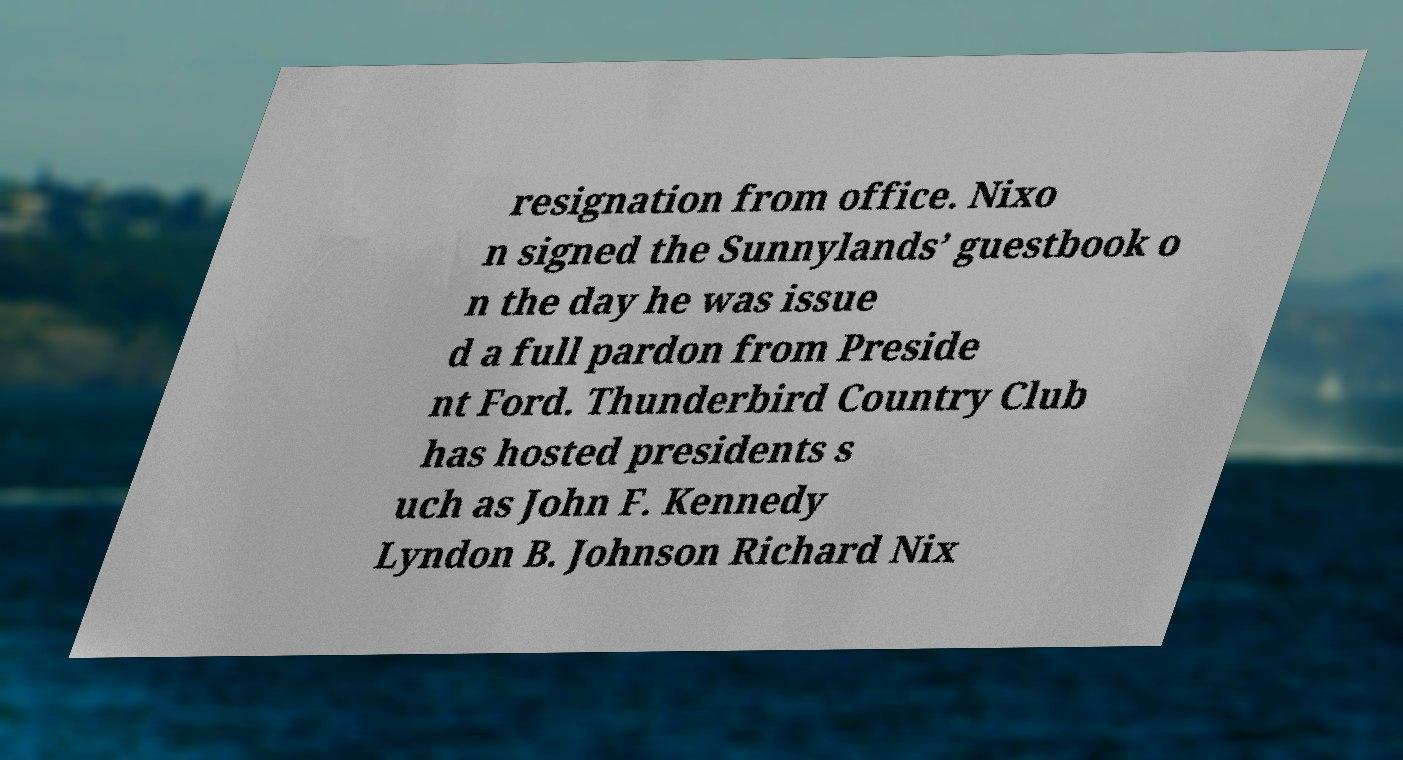I need the written content from this picture converted into text. Can you do that? resignation from office. Nixo n signed the Sunnylands’ guestbook o n the day he was issue d a full pardon from Preside nt Ford. Thunderbird Country Club has hosted presidents s uch as John F. Kennedy Lyndon B. Johnson Richard Nix 